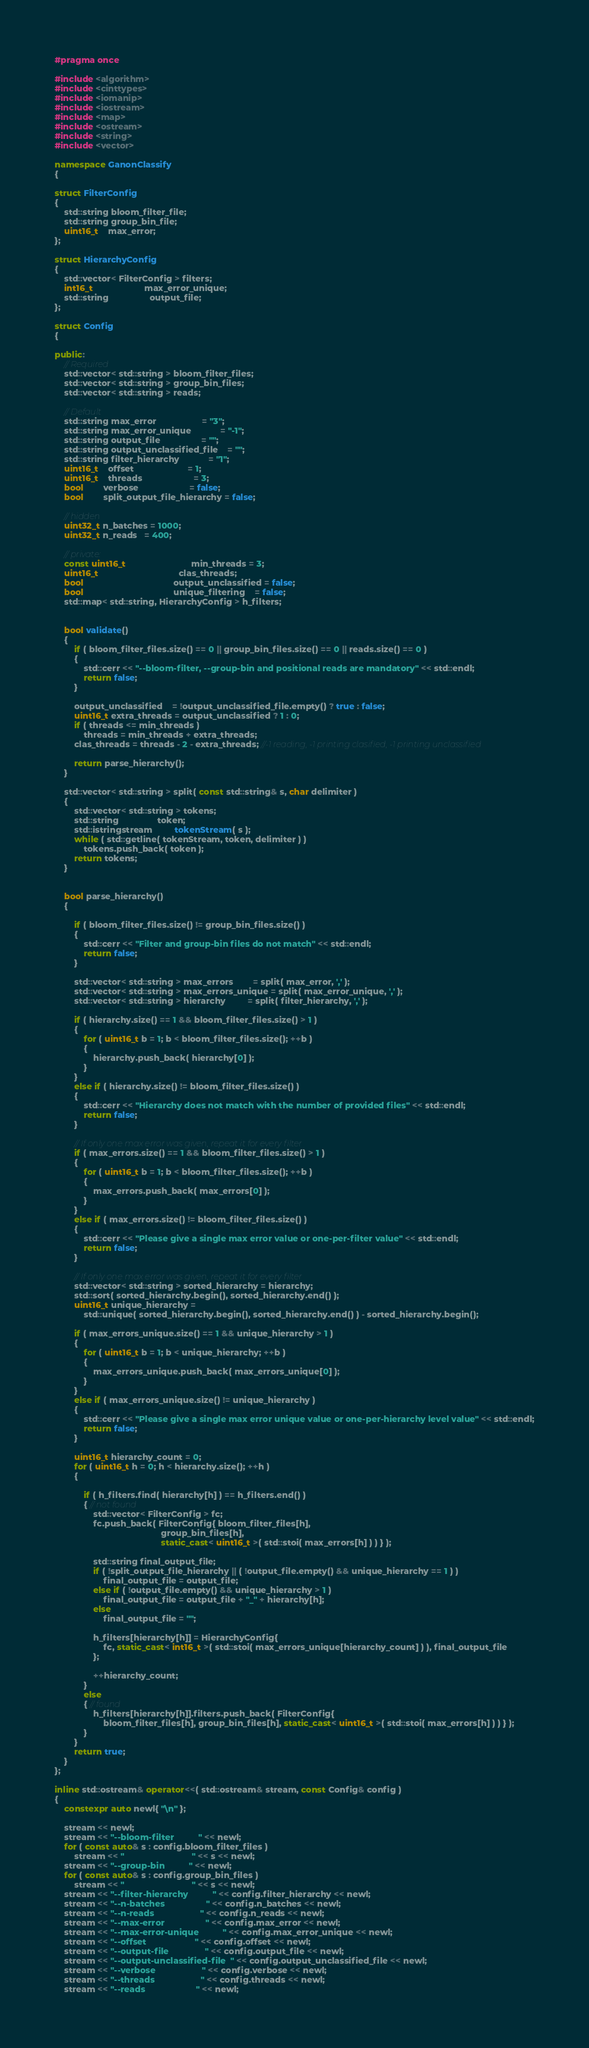<code> <loc_0><loc_0><loc_500><loc_500><_C++_>#pragma once

#include <algorithm>
#include <cinttypes>
#include <iomanip>
#include <iostream>
#include <map>
#include <ostream>
#include <string>
#include <vector>

namespace GanonClassify
{

struct FilterConfig
{
    std::string bloom_filter_file;
    std::string group_bin_file;
    uint16_t    max_error;
};

struct HierarchyConfig
{
    std::vector< FilterConfig > filters;
    int16_t                     max_error_unique;
    std::string                 output_file;
};

struct Config
{

public:
    // Required
    std::vector< std::string > bloom_filter_files;
    std::vector< std::string > group_bin_files;
    std::vector< std::string > reads;

    // Default
    std::string max_error                   = "3";
    std::string max_error_unique            = "-1";
    std::string output_file                 = "";
    std::string output_unclassified_file    = "";
    std::string filter_hierarchy            = "1";
    uint16_t    offset                      = 1;
    uint16_t    threads                     = 3;
    bool        verbose                     = false;
    bool        split_output_file_hierarchy = false;

    // hidden
    uint32_t n_batches = 1000;
    uint32_t n_reads   = 400;

    // private:
    const uint16_t                           min_threads = 3;
    uint16_t                                 clas_threads;
    bool                                     output_unclassified = false;
    bool                                     unique_filtering    = false;
    std::map< std::string, HierarchyConfig > h_filters;


    bool validate()
    {
        if ( bloom_filter_files.size() == 0 || group_bin_files.size() == 0 || reads.size() == 0 )
        {
            std::cerr << "--bloom-filter, --group-bin and positional reads are mandatory" << std::endl;
            return false;
        }

        output_unclassified    = !output_unclassified_file.empty() ? true : false;
        uint16_t extra_threads = output_unclassified ? 1 : 0;
        if ( threads <= min_threads )
            threads = min_threads + extra_threads;
        clas_threads = threads - 2 - extra_threads; //-1 reading, -1 printing clasified, -1 printing unclassified

        return parse_hierarchy();
    }

    std::vector< std::string > split( const std::string& s, char delimiter )
    {
        std::vector< std::string > tokens;
        std::string                token;
        std::istringstream         tokenStream( s );
        while ( std::getline( tokenStream, token, delimiter ) )
            tokens.push_back( token );
        return tokens;
    }


    bool parse_hierarchy()
    {

        if ( bloom_filter_files.size() != group_bin_files.size() )
        {
            std::cerr << "Filter and group-bin files do not match" << std::endl;
            return false;
        }

        std::vector< std::string > max_errors        = split( max_error, ',' );
        std::vector< std::string > max_errors_unique = split( max_error_unique, ',' );
        std::vector< std::string > hierarchy         = split( filter_hierarchy, ',' );

        if ( hierarchy.size() == 1 && bloom_filter_files.size() > 1 )
        {
            for ( uint16_t b = 1; b < bloom_filter_files.size(); ++b )
            {
                hierarchy.push_back( hierarchy[0] );
            }
        }
        else if ( hierarchy.size() != bloom_filter_files.size() )
        {
            std::cerr << "Hierarchy does not match with the number of provided files" << std::endl;
            return false;
        }

        // If only one max error was given, repeat it for every filter
        if ( max_errors.size() == 1 && bloom_filter_files.size() > 1 )
        {
            for ( uint16_t b = 1; b < bloom_filter_files.size(); ++b )
            {
                max_errors.push_back( max_errors[0] );
            }
        }
        else if ( max_errors.size() != bloom_filter_files.size() )
        {
            std::cerr << "Please give a single max error value or one-per-filter value" << std::endl;
            return false;
        }

        // If only one max error was given, repeat it for every filter
        std::vector< std::string > sorted_hierarchy = hierarchy;
        std::sort( sorted_hierarchy.begin(), sorted_hierarchy.end() );
        uint16_t unique_hierarchy =
            std::unique( sorted_hierarchy.begin(), sorted_hierarchy.end() ) - sorted_hierarchy.begin();

        if ( max_errors_unique.size() == 1 && unique_hierarchy > 1 )
        {
            for ( uint16_t b = 1; b < unique_hierarchy; ++b )
            {
                max_errors_unique.push_back( max_errors_unique[0] );
            }
        }
        else if ( max_errors_unique.size() != unique_hierarchy )
        {
            std::cerr << "Please give a single max error unique value or one-per-hierarchy level value" << std::endl;
            return false;
        }

        uint16_t hierarchy_count = 0;
        for ( uint16_t h = 0; h < hierarchy.size(); ++h )
        {

            if ( h_filters.find( hierarchy[h] ) == h_filters.end() )
            { // not found
                std::vector< FilterConfig > fc;
                fc.push_back( FilterConfig{ bloom_filter_files[h],
                                            group_bin_files[h],
                                            static_cast< uint16_t >( std::stoi( max_errors[h] ) ) } );

                std::string final_output_file;
                if ( !split_output_file_hierarchy || ( !output_file.empty() && unique_hierarchy == 1 ) )
                    final_output_file = output_file;
                else if ( !output_file.empty() && unique_hierarchy > 1 )
                    final_output_file = output_file + "_" + hierarchy[h];
                else
                    final_output_file = "";

                h_filters[hierarchy[h]] = HierarchyConfig{
                    fc, static_cast< int16_t >( std::stoi( max_errors_unique[hierarchy_count] ) ), final_output_file
                };

                ++hierarchy_count;
            }
            else
            { // found
                h_filters[hierarchy[h]].filters.push_back( FilterConfig{
                    bloom_filter_files[h], group_bin_files[h], static_cast< uint16_t >( std::stoi( max_errors[h] ) ) } );
            }
        }
        return true;
    }
};

inline std::ostream& operator<<( std::ostream& stream, const Config& config )
{
    constexpr auto newl{ "\n" };

    stream << newl;
    stream << "--bloom-filter          " << newl;
    for ( const auto& s : config.bloom_filter_files )
        stream << "                            " << s << newl;
    stream << "--group-bin          " << newl;
    for ( const auto& s : config.group_bin_files )
        stream << "                            " << s << newl;
    stream << "--filter-hierarchy          " << config.filter_hierarchy << newl;
    stream << "--n-batches                 " << config.n_batches << newl;
    stream << "--n-reads                   " << config.n_reads << newl;
    stream << "--max-error                 " << config.max_error << newl;
    stream << "--max-error-unique          " << config.max_error_unique << newl;
    stream << "--offset                    " << config.offset << newl;
    stream << "--output-file               " << config.output_file << newl;
    stream << "--output-unclassified-file  " << config.output_unclassified_file << newl;
    stream << "--verbose                   " << config.verbose << newl;
    stream << "--threads                   " << config.threads << newl;
    stream << "--reads                     " << newl;</code> 